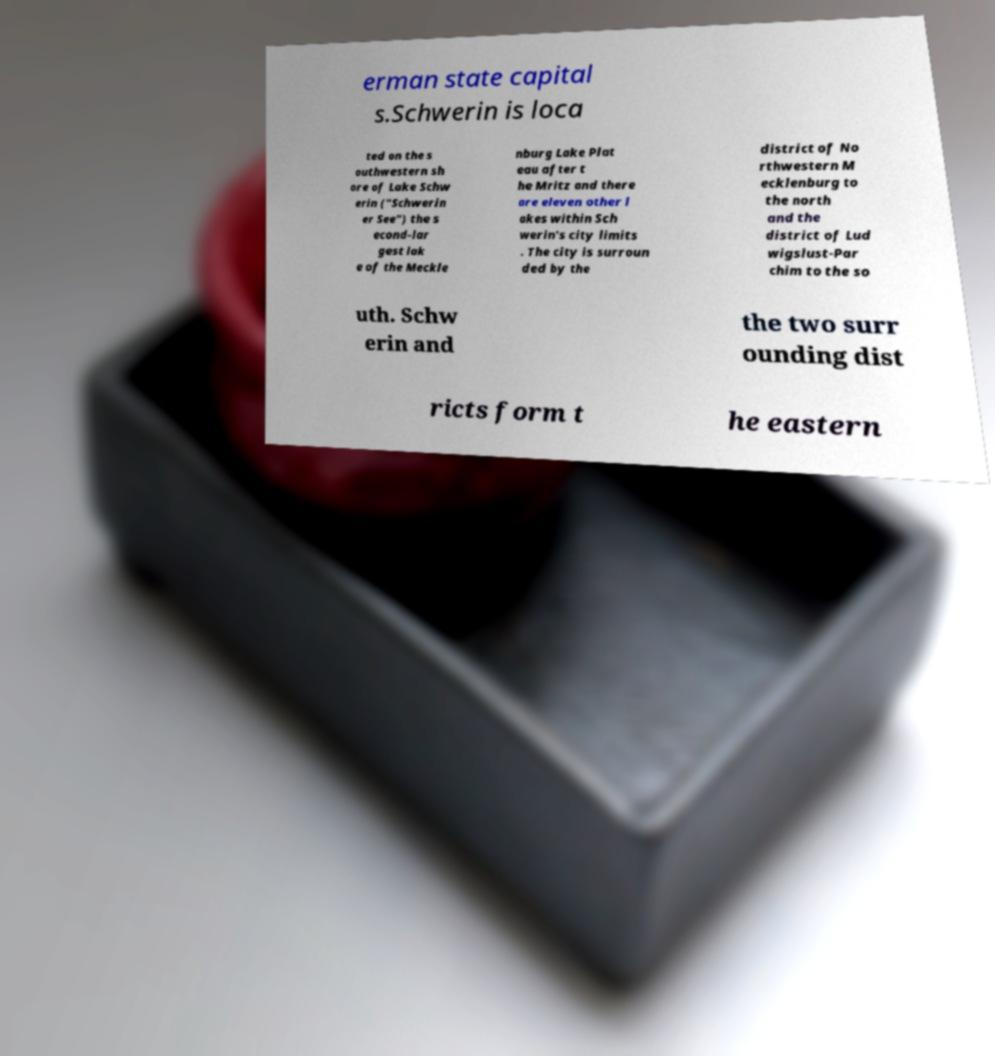For documentation purposes, I need the text within this image transcribed. Could you provide that? erman state capital s.Schwerin is loca ted on the s outhwestern sh ore of Lake Schw erin ("Schwerin er See") the s econd-lar gest lak e of the Meckle nburg Lake Plat eau after t he Mritz and there are eleven other l akes within Sch werin's city limits . The city is surroun ded by the district of No rthwestern M ecklenburg to the north and the district of Lud wigslust-Par chim to the so uth. Schw erin and the two surr ounding dist ricts form t he eastern 